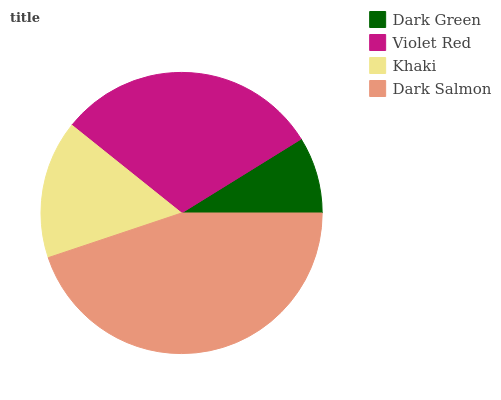Is Dark Green the minimum?
Answer yes or no. Yes. Is Dark Salmon the maximum?
Answer yes or no. Yes. Is Violet Red the minimum?
Answer yes or no. No. Is Violet Red the maximum?
Answer yes or no. No. Is Violet Red greater than Dark Green?
Answer yes or no. Yes. Is Dark Green less than Violet Red?
Answer yes or no. Yes. Is Dark Green greater than Violet Red?
Answer yes or no. No. Is Violet Red less than Dark Green?
Answer yes or no. No. Is Violet Red the high median?
Answer yes or no. Yes. Is Khaki the low median?
Answer yes or no. Yes. Is Dark Green the high median?
Answer yes or no. No. Is Violet Red the low median?
Answer yes or no. No. 